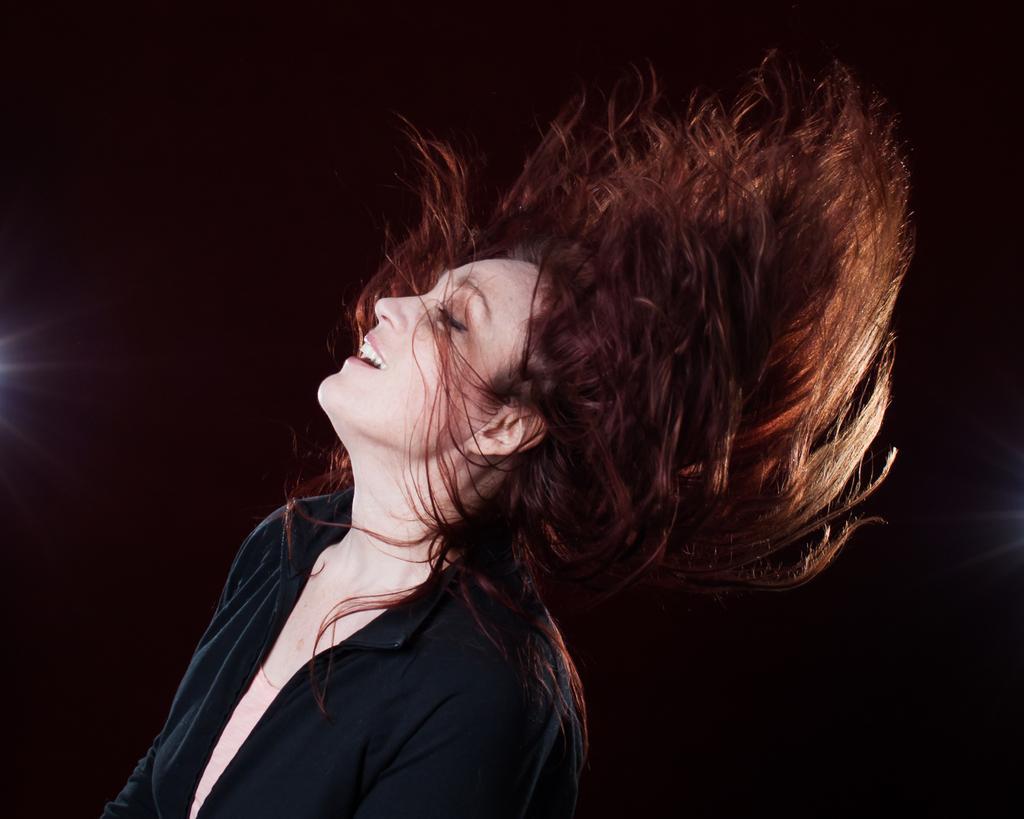How would you summarize this image in a sentence or two? In this picture I can see a woman wearing a black shirt. 